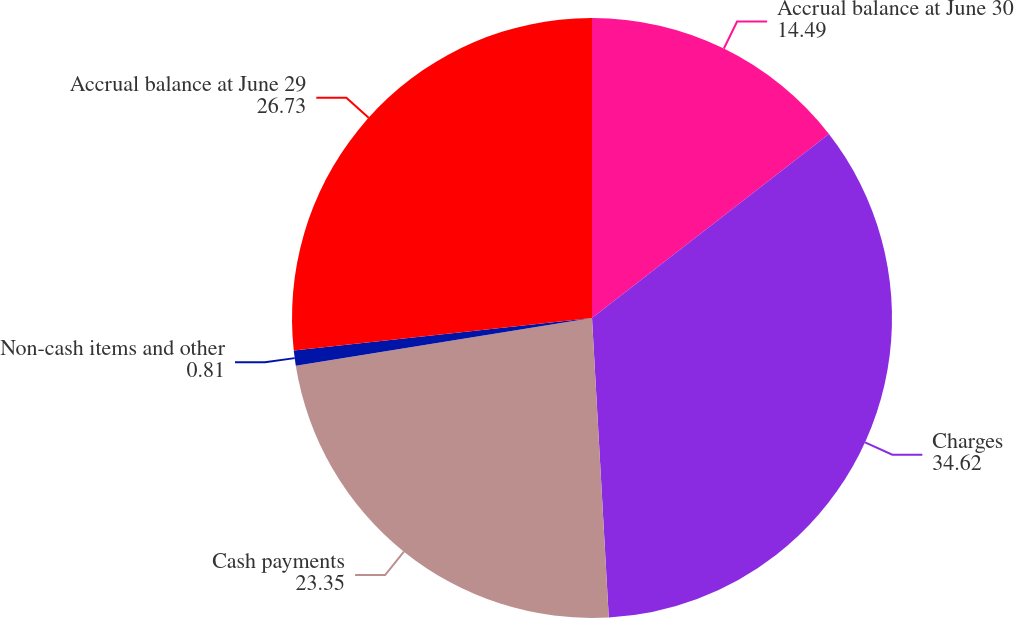Convert chart. <chart><loc_0><loc_0><loc_500><loc_500><pie_chart><fcel>Accrual balance at June 30<fcel>Charges<fcel>Cash payments<fcel>Non-cash items and other<fcel>Accrual balance at June 29<nl><fcel>14.49%<fcel>34.62%<fcel>23.35%<fcel>0.81%<fcel>26.73%<nl></chart> 